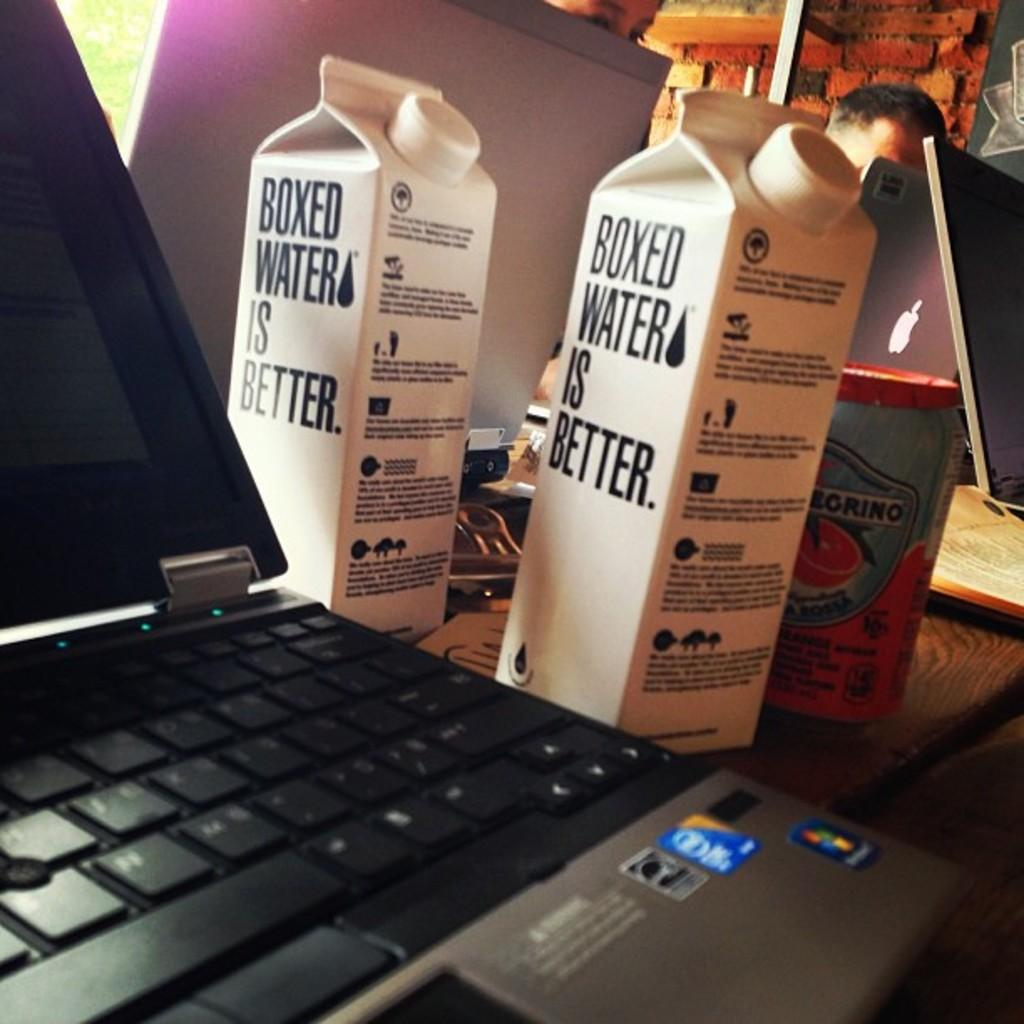Provide a one-sentence caption for the provided image. A computer has two cartons next to it that say boxed water is better on the side. 